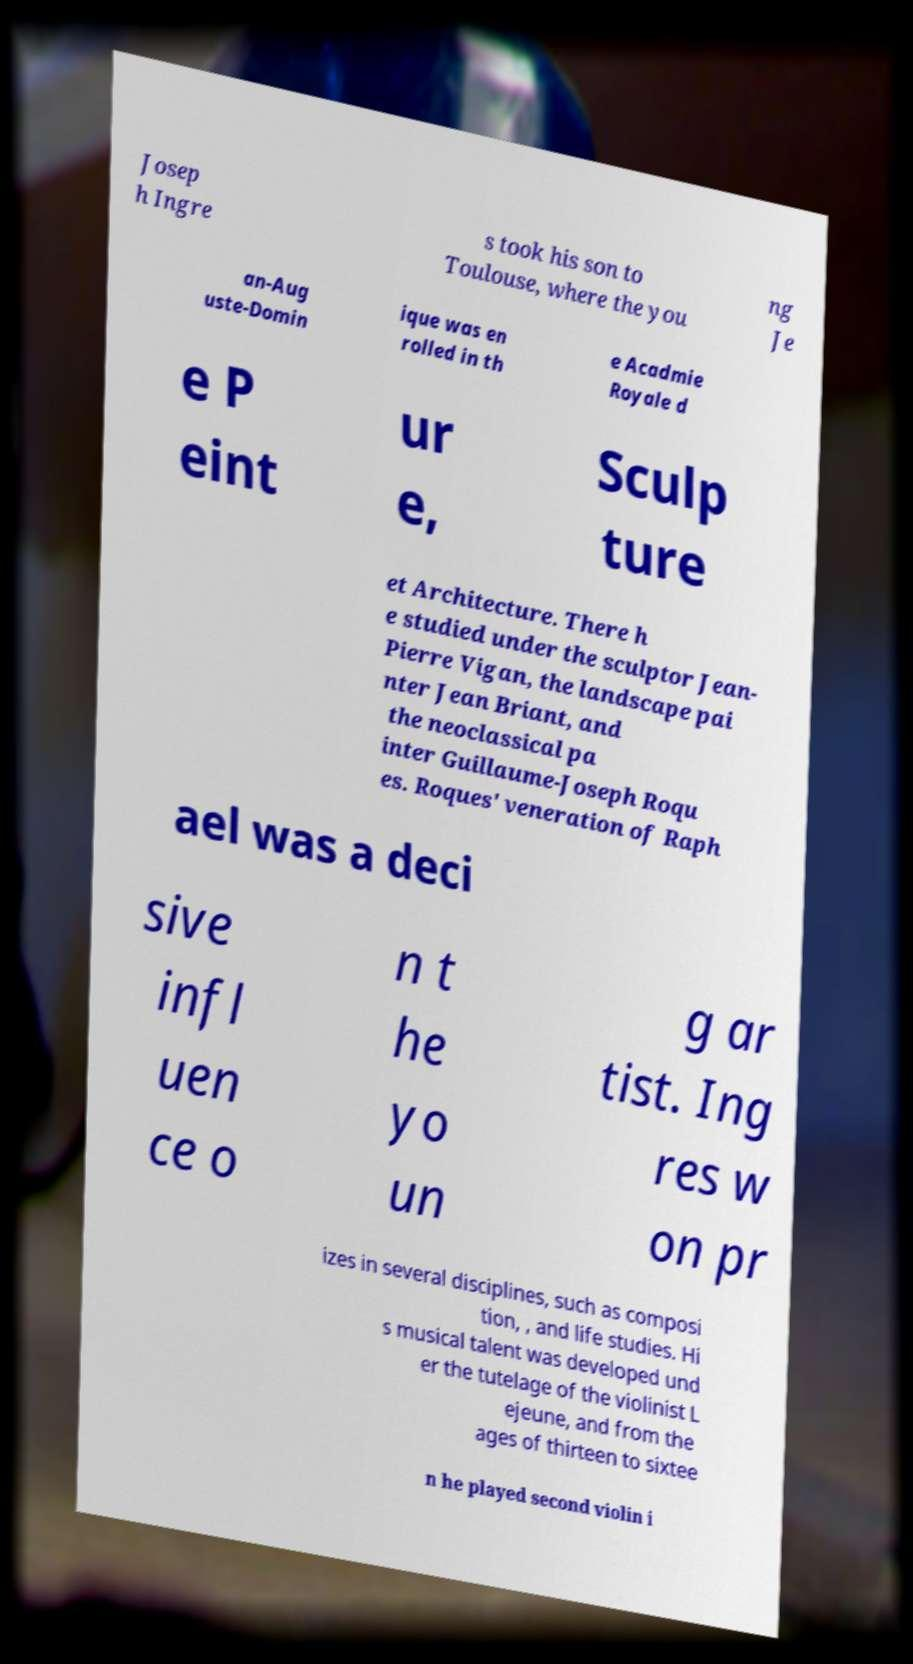I need the written content from this picture converted into text. Can you do that? Josep h Ingre s took his son to Toulouse, where the you ng Je an-Aug uste-Domin ique was en rolled in th e Acadmie Royale d e P eint ur e, Sculp ture et Architecture. There h e studied under the sculptor Jean- Pierre Vigan, the landscape pai nter Jean Briant, and the neoclassical pa inter Guillaume-Joseph Roqu es. Roques' veneration of Raph ael was a deci sive infl uen ce o n t he yo un g ar tist. Ing res w on pr izes in several disciplines, such as composi tion, , and life studies. Hi s musical talent was developed und er the tutelage of the violinist L ejeune, and from the ages of thirteen to sixtee n he played second violin i 